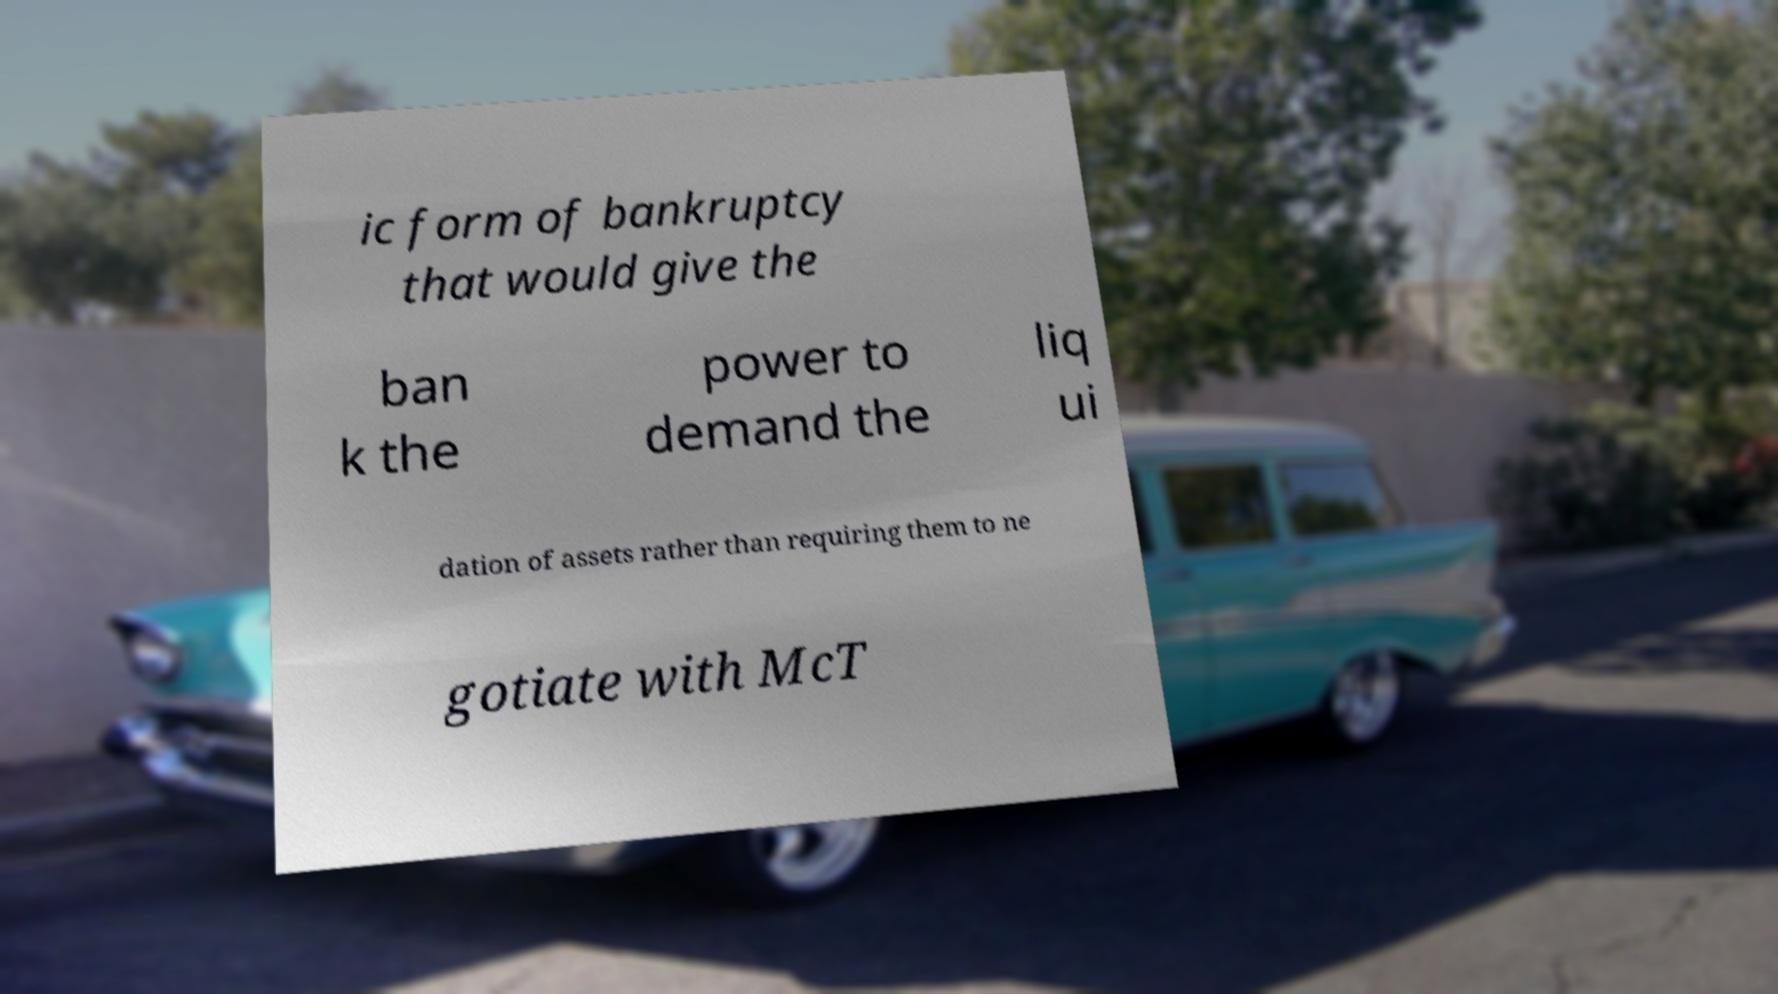Could you extract and type out the text from this image? ic form of bankruptcy that would give the ban k the power to demand the liq ui dation of assets rather than requiring them to ne gotiate with McT 